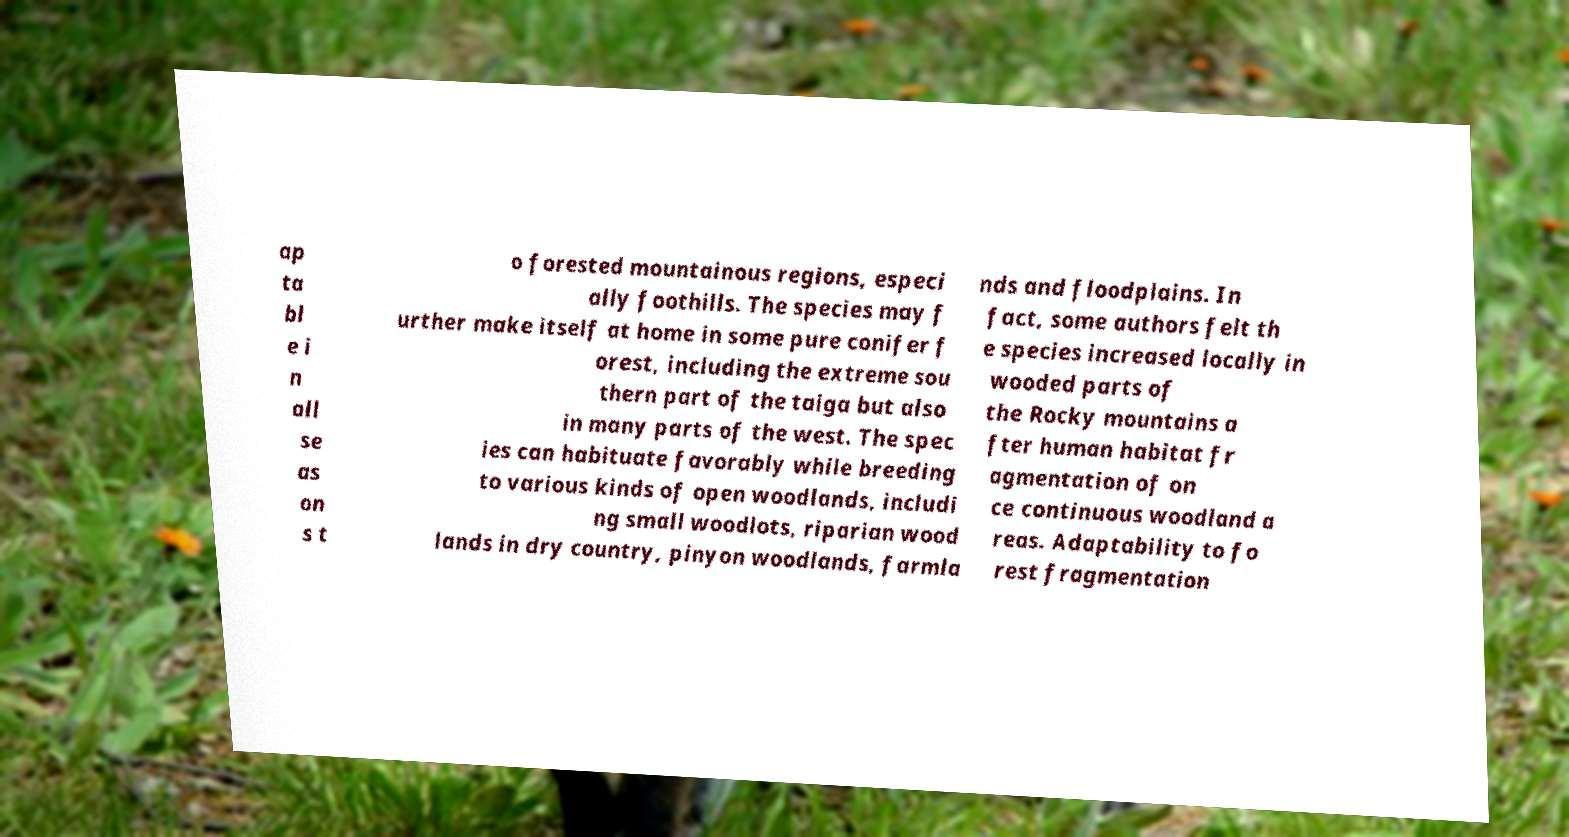Could you extract and type out the text from this image? ap ta bl e i n all se as on s t o forested mountainous regions, especi ally foothills. The species may f urther make itself at home in some pure conifer f orest, including the extreme sou thern part of the taiga but also in many parts of the west. The spec ies can habituate favorably while breeding to various kinds of open woodlands, includi ng small woodlots, riparian wood lands in dry country, pinyon woodlands, farmla nds and floodplains. In fact, some authors felt th e species increased locally in wooded parts of the Rocky mountains a fter human habitat fr agmentation of on ce continuous woodland a reas. Adaptability to fo rest fragmentation 